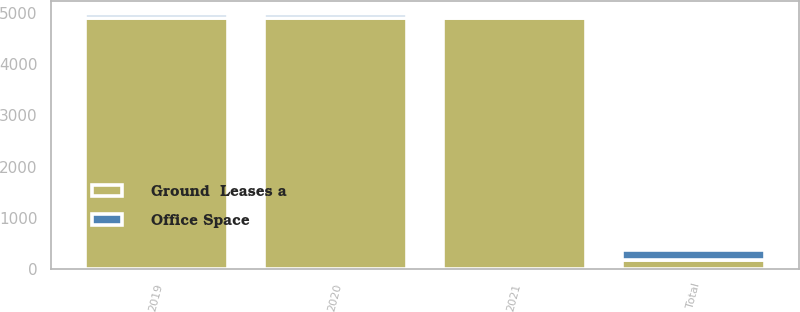Convert chart to OTSL. <chart><loc_0><loc_0><loc_500><loc_500><stacked_bar_chart><ecel><fcel>2019<fcel>2020<fcel>2021<fcel>Total<nl><fcel>Ground  Leases a<fcel>4901<fcel>4901<fcel>4901<fcel>184<nl><fcel>Office Space<fcel>76<fcel>76<fcel>32<fcel>184<nl></chart> 